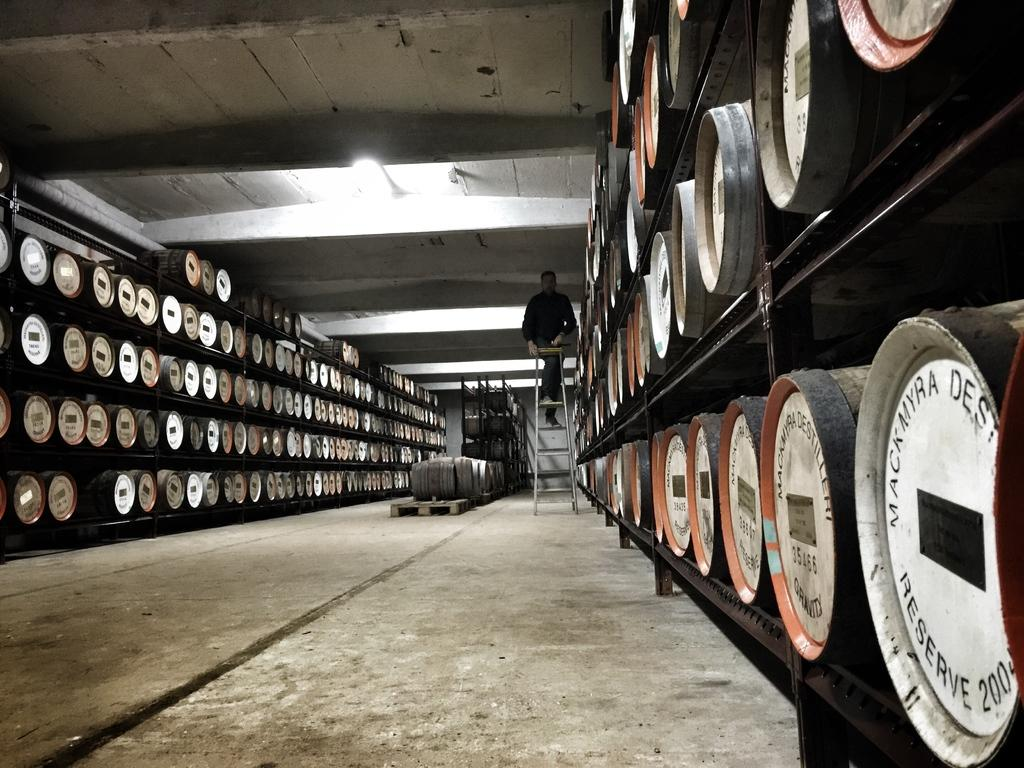What type of musical instruments are in the image? There are drums in the image. How are the drums arranged in the image? The drums are in racks. What is the person in the image doing? There is a person on a ladder in the image. What can be seen at the top of the image? There is a light at the top of the image. What part of the room is visible in the image? The ceiling is visible in the image. What type of receipt is the ladybug holding in the image? There is no ladybug or receipt present in the image. 